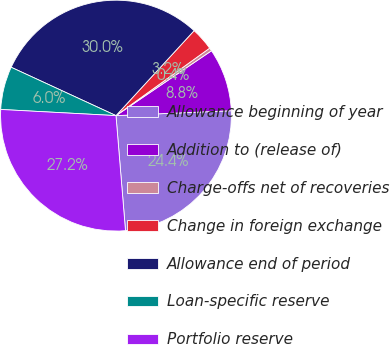Convert chart. <chart><loc_0><loc_0><loc_500><loc_500><pie_chart><fcel>Allowance beginning of year<fcel>Addition to (release of)<fcel>Charge-offs net of recoveries<fcel>Change in foreign exchange<fcel>Allowance end of period<fcel>Loan-specific reserve<fcel>Portfolio reserve<nl><fcel>24.36%<fcel>8.82%<fcel>0.44%<fcel>3.23%<fcel>29.95%<fcel>6.03%<fcel>27.16%<nl></chart> 